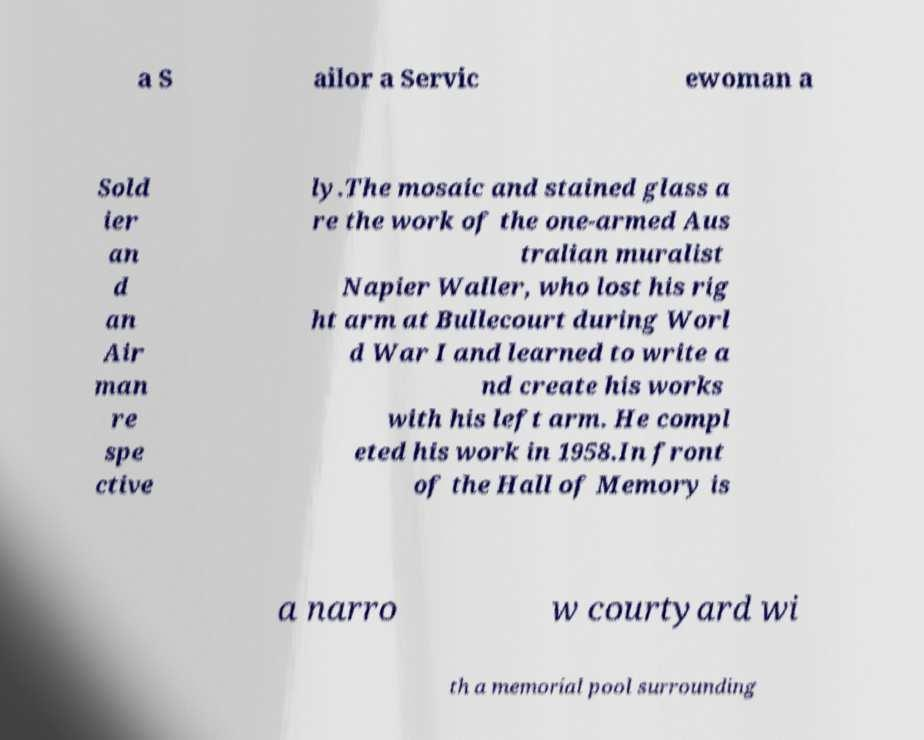Can you accurately transcribe the text from the provided image for me? a S ailor a Servic ewoman a Sold ier an d an Air man re spe ctive ly.The mosaic and stained glass a re the work of the one-armed Aus tralian muralist Napier Waller, who lost his rig ht arm at Bullecourt during Worl d War I and learned to write a nd create his works with his left arm. He compl eted his work in 1958.In front of the Hall of Memory is a narro w courtyard wi th a memorial pool surrounding 